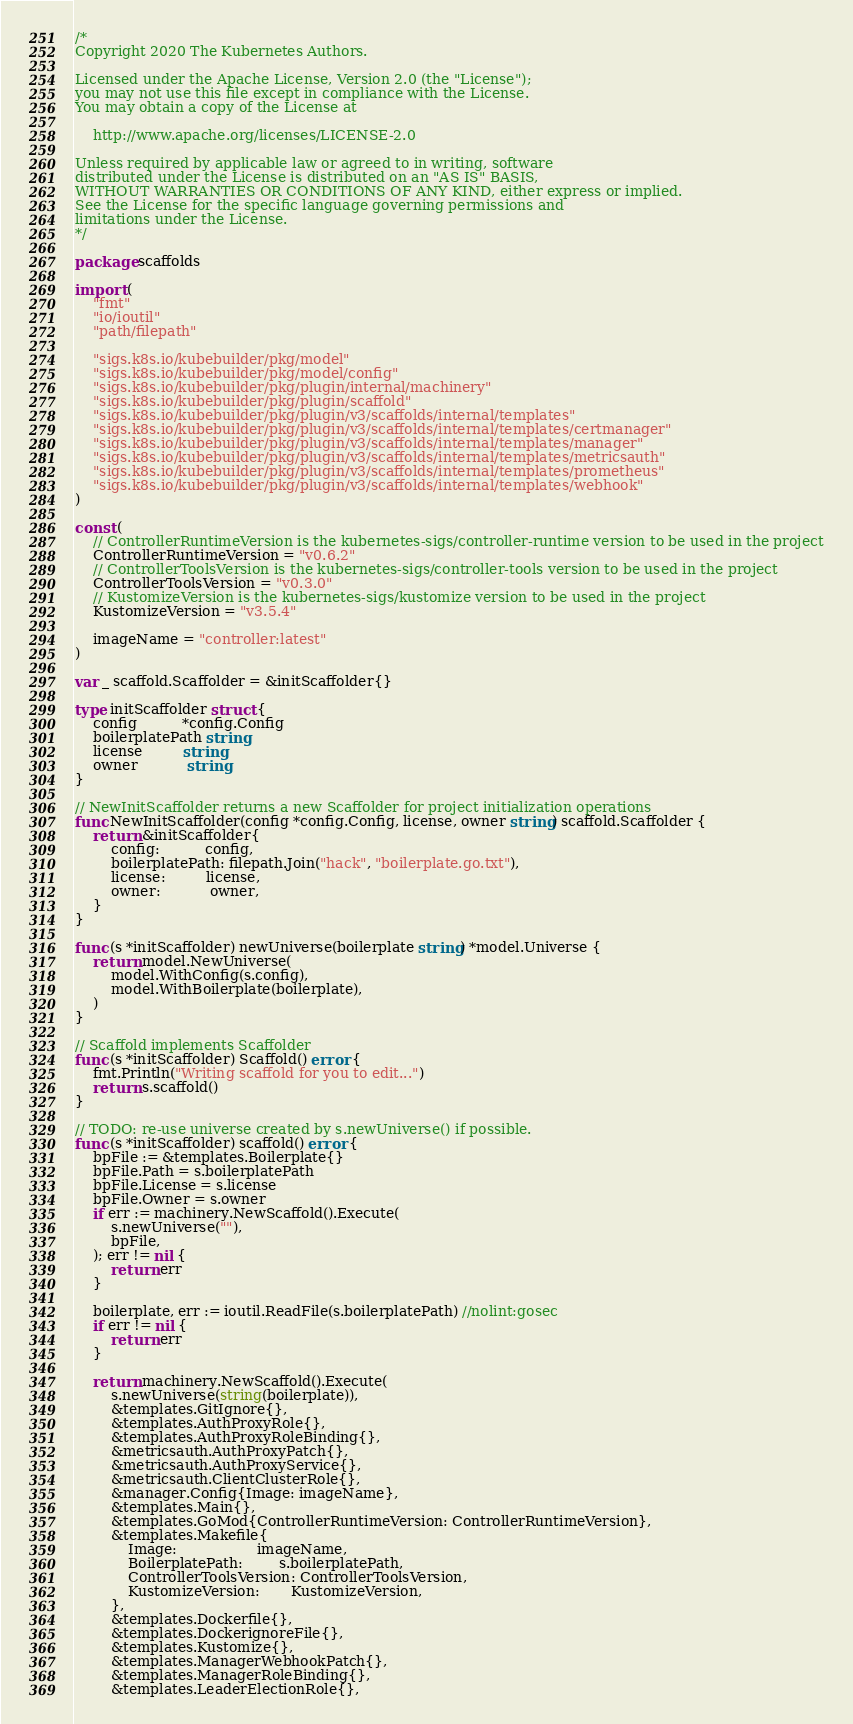Convert code to text. <code><loc_0><loc_0><loc_500><loc_500><_Go_>/*
Copyright 2020 The Kubernetes Authors.

Licensed under the Apache License, Version 2.0 (the "License");
you may not use this file except in compliance with the License.
You may obtain a copy of the License at

    http://www.apache.org/licenses/LICENSE-2.0

Unless required by applicable law or agreed to in writing, software
distributed under the License is distributed on an "AS IS" BASIS,
WITHOUT WARRANTIES OR CONDITIONS OF ANY KIND, either express or implied.
See the License for the specific language governing permissions and
limitations under the License.
*/

package scaffolds

import (
	"fmt"
	"io/ioutil"
	"path/filepath"

	"sigs.k8s.io/kubebuilder/pkg/model"
	"sigs.k8s.io/kubebuilder/pkg/model/config"
	"sigs.k8s.io/kubebuilder/pkg/plugin/internal/machinery"
	"sigs.k8s.io/kubebuilder/pkg/plugin/scaffold"
	"sigs.k8s.io/kubebuilder/pkg/plugin/v3/scaffolds/internal/templates"
	"sigs.k8s.io/kubebuilder/pkg/plugin/v3/scaffolds/internal/templates/certmanager"
	"sigs.k8s.io/kubebuilder/pkg/plugin/v3/scaffolds/internal/templates/manager"
	"sigs.k8s.io/kubebuilder/pkg/plugin/v3/scaffolds/internal/templates/metricsauth"
	"sigs.k8s.io/kubebuilder/pkg/plugin/v3/scaffolds/internal/templates/prometheus"
	"sigs.k8s.io/kubebuilder/pkg/plugin/v3/scaffolds/internal/templates/webhook"
)

const (
	// ControllerRuntimeVersion is the kubernetes-sigs/controller-runtime version to be used in the project
	ControllerRuntimeVersion = "v0.6.2"
	// ControllerToolsVersion is the kubernetes-sigs/controller-tools version to be used in the project
	ControllerToolsVersion = "v0.3.0"
	// KustomizeVersion is the kubernetes-sigs/kustomize version to be used in the project
	KustomizeVersion = "v3.5.4"

	imageName = "controller:latest"
)

var _ scaffold.Scaffolder = &initScaffolder{}

type initScaffolder struct {
	config          *config.Config
	boilerplatePath string
	license         string
	owner           string
}

// NewInitScaffolder returns a new Scaffolder for project initialization operations
func NewInitScaffolder(config *config.Config, license, owner string) scaffold.Scaffolder {
	return &initScaffolder{
		config:          config,
		boilerplatePath: filepath.Join("hack", "boilerplate.go.txt"),
		license:         license,
		owner:           owner,
	}
}

func (s *initScaffolder) newUniverse(boilerplate string) *model.Universe {
	return model.NewUniverse(
		model.WithConfig(s.config),
		model.WithBoilerplate(boilerplate),
	)
}

// Scaffold implements Scaffolder
func (s *initScaffolder) Scaffold() error {
	fmt.Println("Writing scaffold for you to edit...")
	return s.scaffold()
}

// TODO: re-use universe created by s.newUniverse() if possible.
func (s *initScaffolder) scaffold() error {
	bpFile := &templates.Boilerplate{}
	bpFile.Path = s.boilerplatePath
	bpFile.License = s.license
	bpFile.Owner = s.owner
	if err := machinery.NewScaffold().Execute(
		s.newUniverse(""),
		bpFile,
	); err != nil {
		return err
	}

	boilerplate, err := ioutil.ReadFile(s.boilerplatePath) //nolint:gosec
	if err != nil {
		return err
	}

	return machinery.NewScaffold().Execute(
		s.newUniverse(string(boilerplate)),
		&templates.GitIgnore{},
		&templates.AuthProxyRole{},
		&templates.AuthProxyRoleBinding{},
		&metricsauth.AuthProxyPatch{},
		&metricsauth.AuthProxyService{},
		&metricsauth.ClientClusterRole{},
		&manager.Config{Image: imageName},
		&templates.Main{},
		&templates.GoMod{ControllerRuntimeVersion: ControllerRuntimeVersion},
		&templates.Makefile{
			Image:                  imageName,
			BoilerplatePath:        s.boilerplatePath,
			ControllerToolsVersion: ControllerToolsVersion,
			KustomizeVersion:       KustomizeVersion,
		},
		&templates.Dockerfile{},
		&templates.DockerignoreFile{},
		&templates.Kustomize{},
		&templates.ManagerWebhookPatch{},
		&templates.ManagerRoleBinding{},
		&templates.LeaderElectionRole{},</code> 